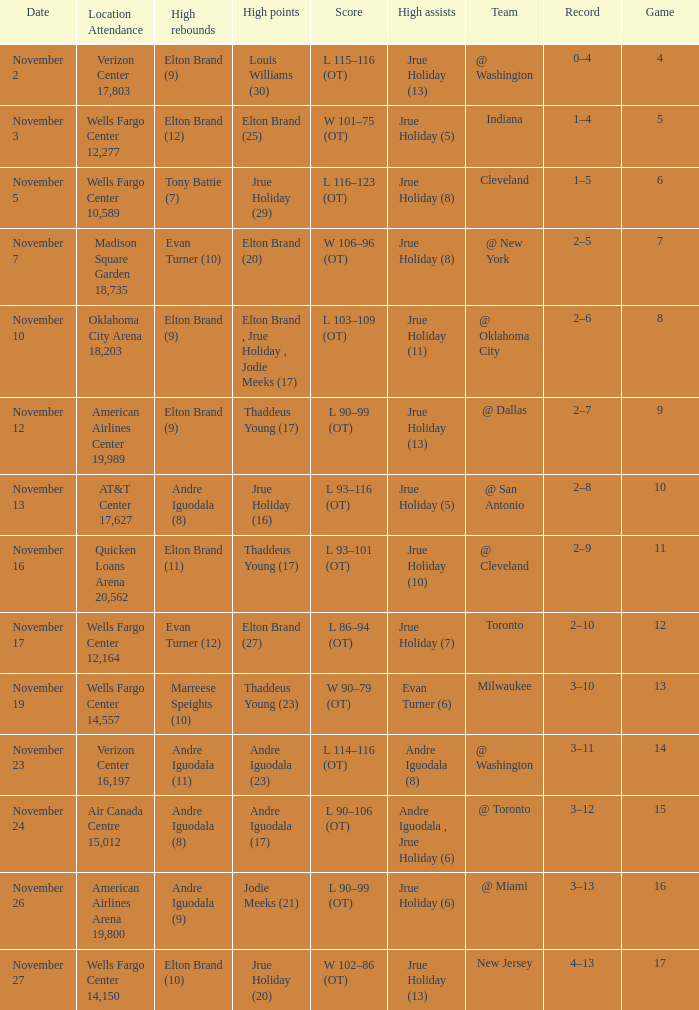How many games are shown for the game where andre iguodala (9) had the high rebounds? 1.0. 